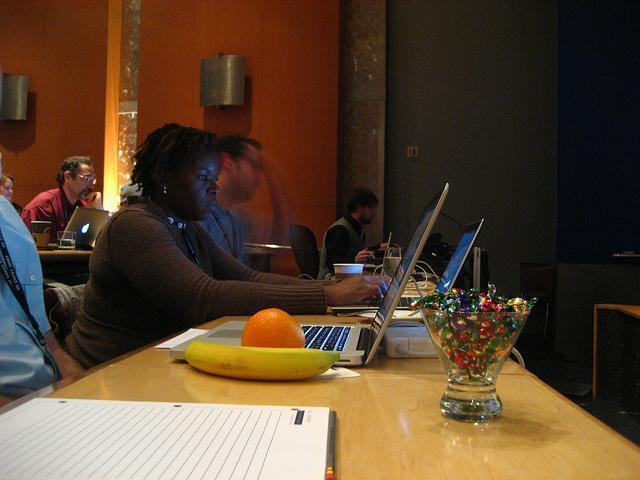Which food is the most unhealthy?
Select the accurate answer and provide explanation: 'Answer: answer
Rationale: rationale.'
Options: Banana, candy, coffee, orange. Answer: candy.
Rationale: The candies are the most unhealthy food here. 